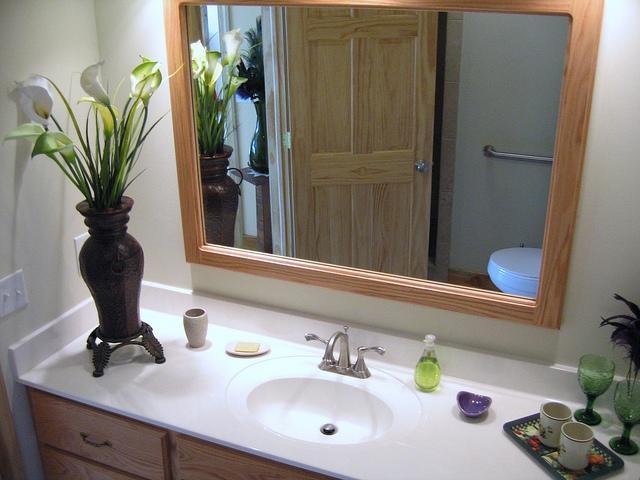How many vases are there?
Give a very brief answer. 2. 